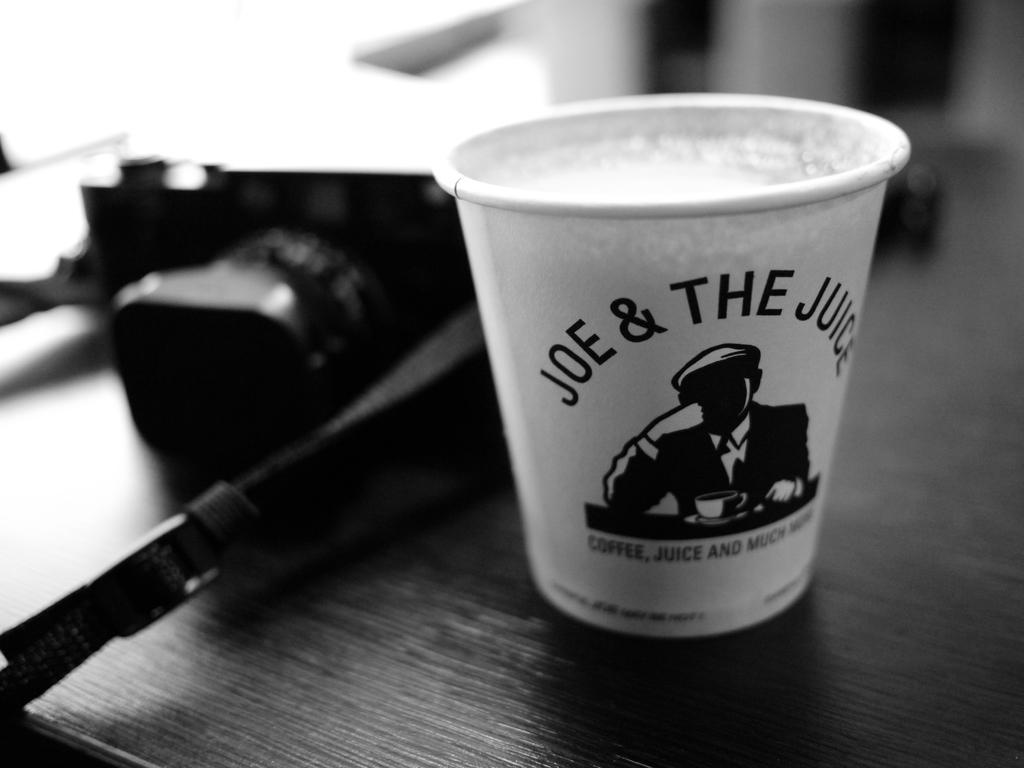<image>
Render a clear and concise summary of the photo. a small cup that says 'joe & the juice' on it 